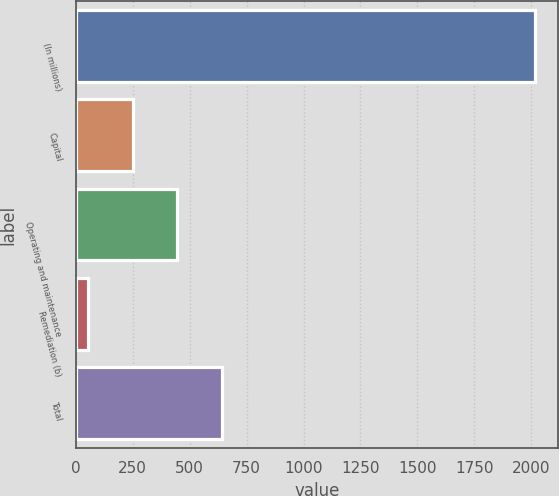Convert chart to OTSL. <chart><loc_0><loc_0><loc_500><loc_500><bar_chart><fcel>(In millions)<fcel>Capital<fcel>Operating and maintenance<fcel>Remediation (b)<fcel>Total<nl><fcel>2015<fcel>249.2<fcel>445.4<fcel>53<fcel>641.6<nl></chart> 